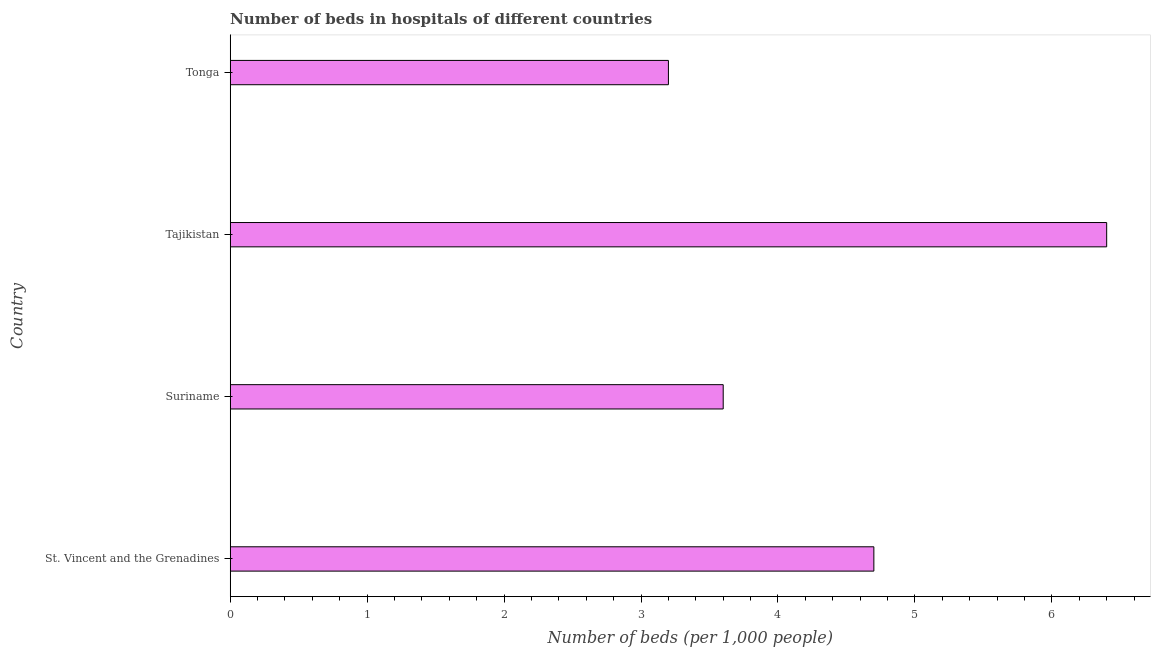Does the graph contain any zero values?
Ensure brevity in your answer.  No. Does the graph contain grids?
Your answer should be compact. No. What is the title of the graph?
Your response must be concise. Number of beds in hospitals of different countries. What is the label or title of the X-axis?
Your response must be concise. Number of beds (per 1,0 people). What is the label or title of the Y-axis?
Give a very brief answer. Country. What is the number of hospital beds in Tajikistan?
Offer a very short reply. 6.4. Across all countries, what is the maximum number of hospital beds?
Provide a succinct answer. 6.4. Across all countries, what is the minimum number of hospital beds?
Provide a short and direct response. 3.2. In which country was the number of hospital beds maximum?
Ensure brevity in your answer.  Tajikistan. In which country was the number of hospital beds minimum?
Keep it short and to the point. Tonga. What is the sum of the number of hospital beds?
Provide a succinct answer. 17.9. What is the difference between the number of hospital beds in Suriname and Tajikistan?
Provide a short and direct response. -2.8. What is the average number of hospital beds per country?
Offer a very short reply. 4.47. What is the median number of hospital beds?
Ensure brevity in your answer.  4.15. In how many countries, is the number of hospital beds greater than 2 %?
Ensure brevity in your answer.  4. Is the number of hospital beds in Suriname less than that in Tonga?
Give a very brief answer. No. Is the difference between the number of hospital beds in St. Vincent and the Grenadines and Tajikistan greater than the difference between any two countries?
Provide a short and direct response. No. What is the difference between the highest and the second highest number of hospital beds?
Your response must be concise. 1.7. What is the difference between the highest and the lowest number of hospital beds?
Your answer should be compact. 3.2. How many bars are there?
Your response must be concise. 4. Are all the bars in the graph horizontal?
Offer a very short reply. Yes. How many countries are there in the graph?
Ensure brevity in your answer.  4. What is the difference between two consecutive major ticks on the X-axis?
Your answer should be compact. 1. What is the Number of beds (per 1,000 people) in St. Vincent and the Grenadines?
Your response must be concise. 4.7. What is the Number of beds (per 1,000 people) in Suriname?
Offer a terse response. 3.6. What is the Number of beds (per 1,000 people) in Tajikistan?
Your response must be concise. 6.4. What is the Number of beds (per 1,000 people) in Tonga?
Make the answer very short. 3.2. What is the difference between the Number of beds (per 1,000 people) in St. Vincent and the Grenadines and Tonga?
Your response must be concise. 1.5. What is the difference between the Number of beds (per 1,000 people) in Suriname and Tajikistan?
Your response must be concise. -2.8. What is the ratio of the Number of beds (per 1,000 people) in St. Vincent and the Grenadines to that in Suriname?
Your response must be concise. 1.31. What is the ratio of the Number of beds (per 1,000 people) in St. Vincent and the Grenadines to that in Tajikistan?
Ensure brevity in your answer.  0.73. What is the ratio of the Number of beds (per 1,000 people) in St. Vincent and the Grenadines to that in Tonga?
Ensure brevity in your answer.  1.47. What is the ratio of the Number of beds (per 1,000 people) in Suriname to that in Tajikistan?
Offer a very short reply. 0.56. 